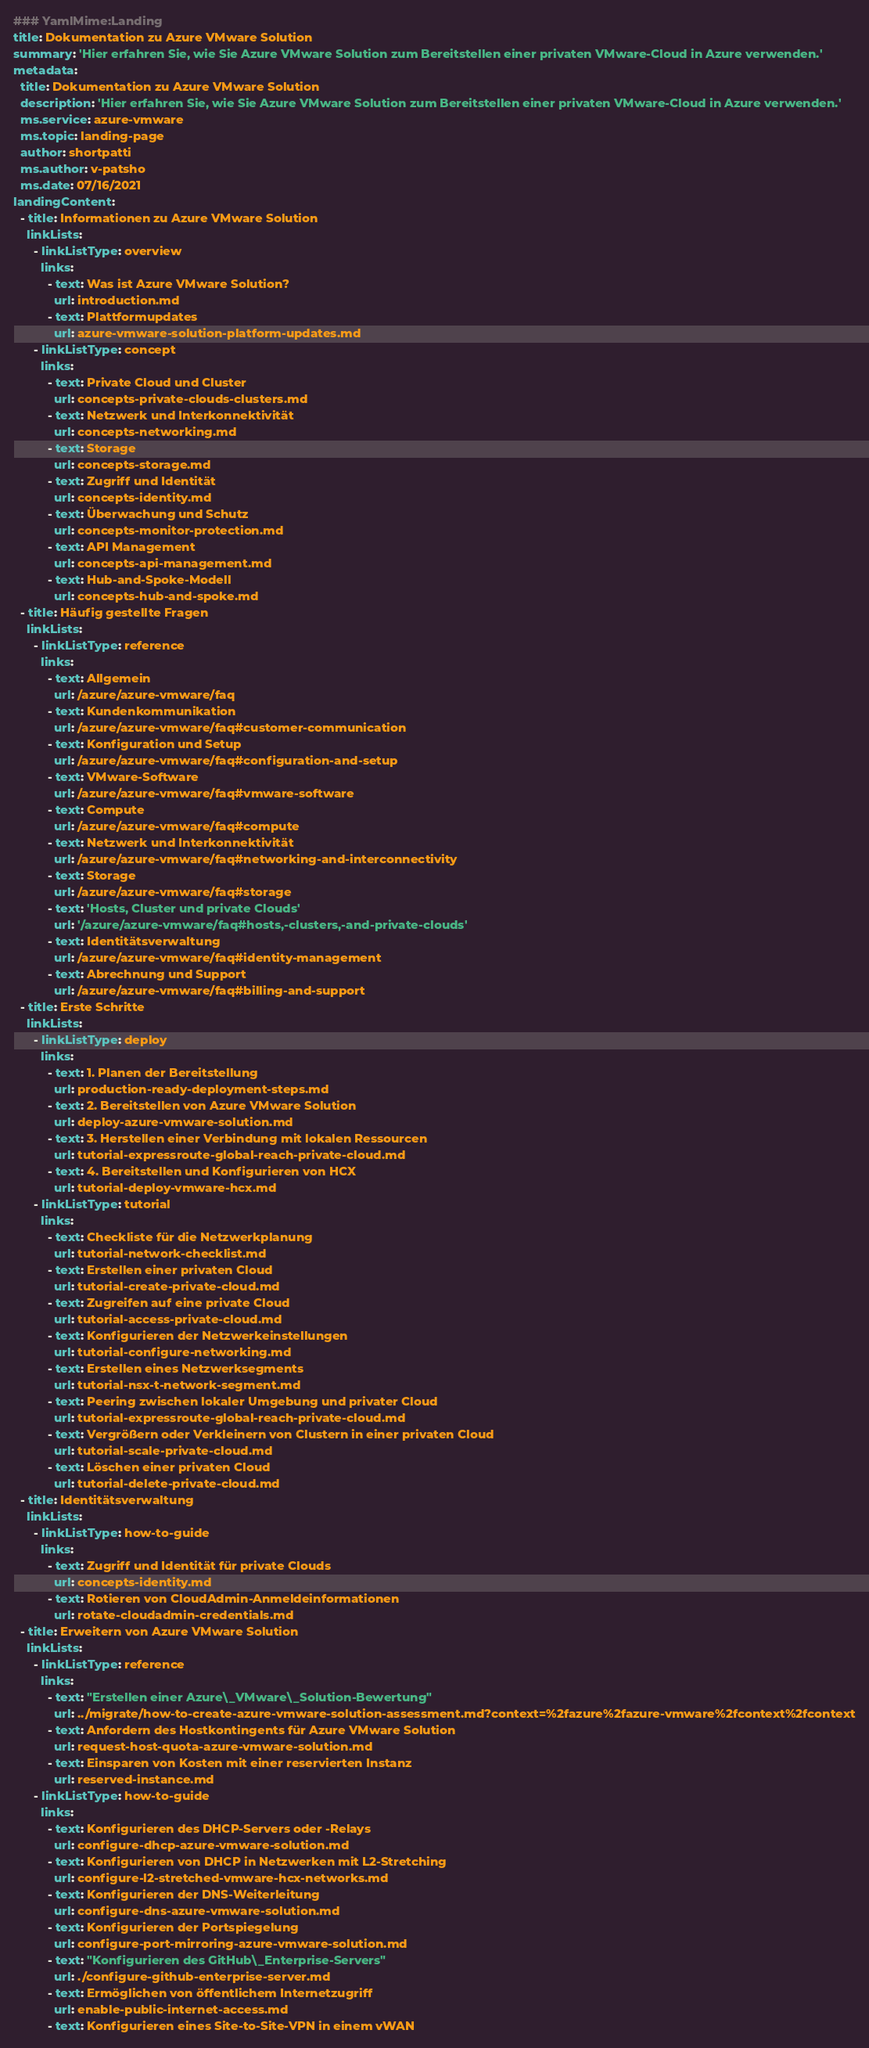Convert code to text. <code><loc_0><loc_0><loc_500><loc_500><_YAML_>### YamlMime:Landing
title: Dokumentation zu Azure VMware Solution
summary: 'Hier erfahren Sie, wie Sie Azure VMware Solution zum Bereitstellen einer privaten VMware-Cloud in Azure verwenden.'
metadata:
  title: Dokumentation zu Azure VMware Solution
  description: 'Hier erfahren Sie, wie Sie Azure VMware Solution zum Bereitstellen einer privaten VMware-Cloud in Azure verwenden.'
  ms.service: azure-vmware
  ms.topic: landing-page
  author: shortpatti
  ms.author: v-patsho
  ms.date: 07/16/2021
landingContent:
  - title: Informationen zu Azure VMware Solution
    linkLists:
      - linkListType: overview
        links:
          - text: Was ist Azure VMware Solution?
            url: introduction.md
          - text: Plattformupdates
            url: azure-vmware-solution-platform-updates.md
      - linkListType: concept
        links:
          - text: Private Cloud und Cluster
            url: concepts-private-clouds-clusters.md
          - text: Netzwerk und Interkonnektivität
            url: concepts-networking.md
          - text: Storage
            url: concepts-storage.md
          - text: Zugriff und Identität
            url: concepts-identity.md
          - text: Überwachung und Schutz
            url: concepts-monitor-protection.md
          - text: API Management
            url: concepts-api-management.md
          - text: Hub-and-Spoke-Modell
            url: concepts-hub-and-spoke.md
  - title: Häufig gestellte Fragen
    linkLists:
      - linkListType: reference
        links:
          - text: Allgemein
            url: /azure/azure-vmware/faq
          - text: Kundenkommunikation
            url: /azure/azure-vmware/faq#customer-communication
          - text: Konfiguration und Setup
            url: /azure/azure-vmware/faq#configuration-and-setup
          - text: VMware-Software
            url: /azure/azure-vmware/faq#vmware-software
          - text: Compute
            url: /azure/azure-vmware/faq#compute
          - text: Netzwerk und Interkonnektivität
            url: /azure/azure-vmware/faq#networking-and-interconnectivity
          - text: Storage
            url: /azure/azure-vmware/faq#storage
          - text: 'Hosts, Cluster und private Clouds'
            url: '/azure/azure-vmware/faq#hosts,-clusters,-and-private-clouds'
          - text: Identitätsverwaltung
            url: /azure/azure-vmware/faq#identity-management
          - text: Abrechnung und Support
            url: /azure/azure-vmware/faq#billing-and-support
  - title: Erste Schritte
    linkLists:
      - linkListType: deploy
        links:
          - text: 1. Planen der Bereitstellung
            url: production-ready-deployment-steps.md
          - text: 2. Bereitstellen von Azure VMware Solution
            url: deploy-azure-vmware-solution.md
          - text: 3. Herstellen einer Verbindung mit lokalen Ressourcen
            url: tutorial-expressroute-global-reach-private-cloud.md
          - text: 4. Bereitstellen und Konfigurieren von HCX
            url: tutorial-deploy-vmware-hcx.md
      - linkListType: tutorial
        links:
          - text: Checkliste für die Netzwerkplanung
            url: tutorial-network-checklist.md
          - text: Erstellen einer privaten Cloud
            url: tutorial-create-private-cloud.md
          - text: Zugreifen auf eine private Cloud
            url: tutorial-access-private-cloud.md
          - text: Konfigurieren der Netzwerkeinstellungen
            url: tutorial-configure-networking.md
          - text: Erstellen eines Netzwerksegments
            url: tutorial-nsx-t-network-segment.md
          - text: Peering zwischen lokaler Umgebung und privater Cloud
            url: tutorial-expressroute-global-reach-private-cloud.md
          - text: Vergrößern oder Verkleinern von Clustern in einer privaten Cloud
            url: tutorial-scale-private-cloud.md
          - text: Löschen einer privaten Cloud
            url: tutorial-delete-private-cloud.md
  - title: Identitätsverwaltung
    linkLists:
      - linkListType: how-to-guide
        links:
          - text: Zugriff und Identität für private Clouds
            url: concepts-identity.md
          - text: Rotieren von CloudAdmin-Anmeldeinformationen
            url: rotate-cloudadmin-credentials.md
  - title: Erweitern von Azure VMware Solution
    linkLists:
      - linkListType: reference
        links:
          - text: "Erstellen einer Azure\_VMware\_Solution-Bewertung"
            url: ../migrate/how-to-create-azure-vmware-solution-assessment.md?context=%2fazure%2fazure-vmware%2fcontext%2fcontext
          - text: Anfordern des Hostkontingents für Azure VMware Solution
            url: request-host-quota-azure-vmware-solution.md
          - text: Einsparen von Kosten mit einer reservierten Instanz
            url: reserved-instance.md
      - linkListType: how-to-guide
        links:
          - text: Konfigurieren des DHCP-Servers oder -Relays
            url: configure-dhcp-azure-vmware-solution.md
          - text: Konfigurieren von DHCP in Netzwerken mit L2-Stretching
            url: configure-l2-stretched-vmware-hcx-networks.md
          - text: Konfigurieren der DNS-Weiterleitung
            url: configure-dns-azure-vmware-solution.md
          - text: Konfigurieren der Portspiegelung
            url: configure-port-mirroring-azure-vmware-solution.md
          - text: "Konfigurieren des GitHub\_Enterprise-Servers"
            url: ./configure-github-enterprise-server.md
          - text: Ermöglichen von öffentlichem Internetzugriff
            url: enable-public-internet-access.md
          - text: Konfigurieren eines Site-to-Site-VPN in einem vWAN</code> 